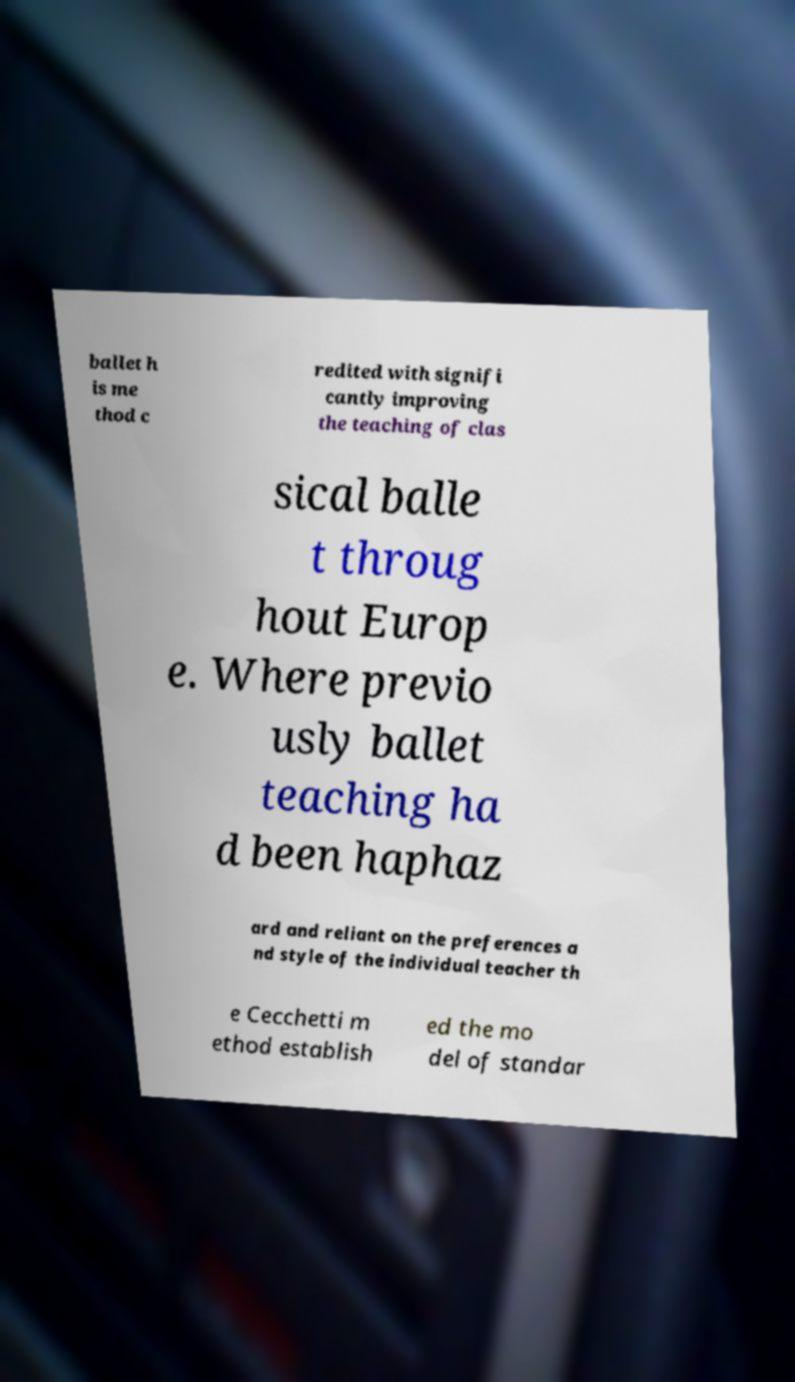There's text embedded in this image that I need extracted. Can you transcribe it verbatim? ballet h is me thod c redited with signifi cantly improving the teaching of clas sical balle t throug hout Europ e. Where previo usly ballet teaching ha d been haphaz ard and reliant on the preferences a nd style of the individual teacher th e Cecchetti m ethod establish ed the mo del of standar 